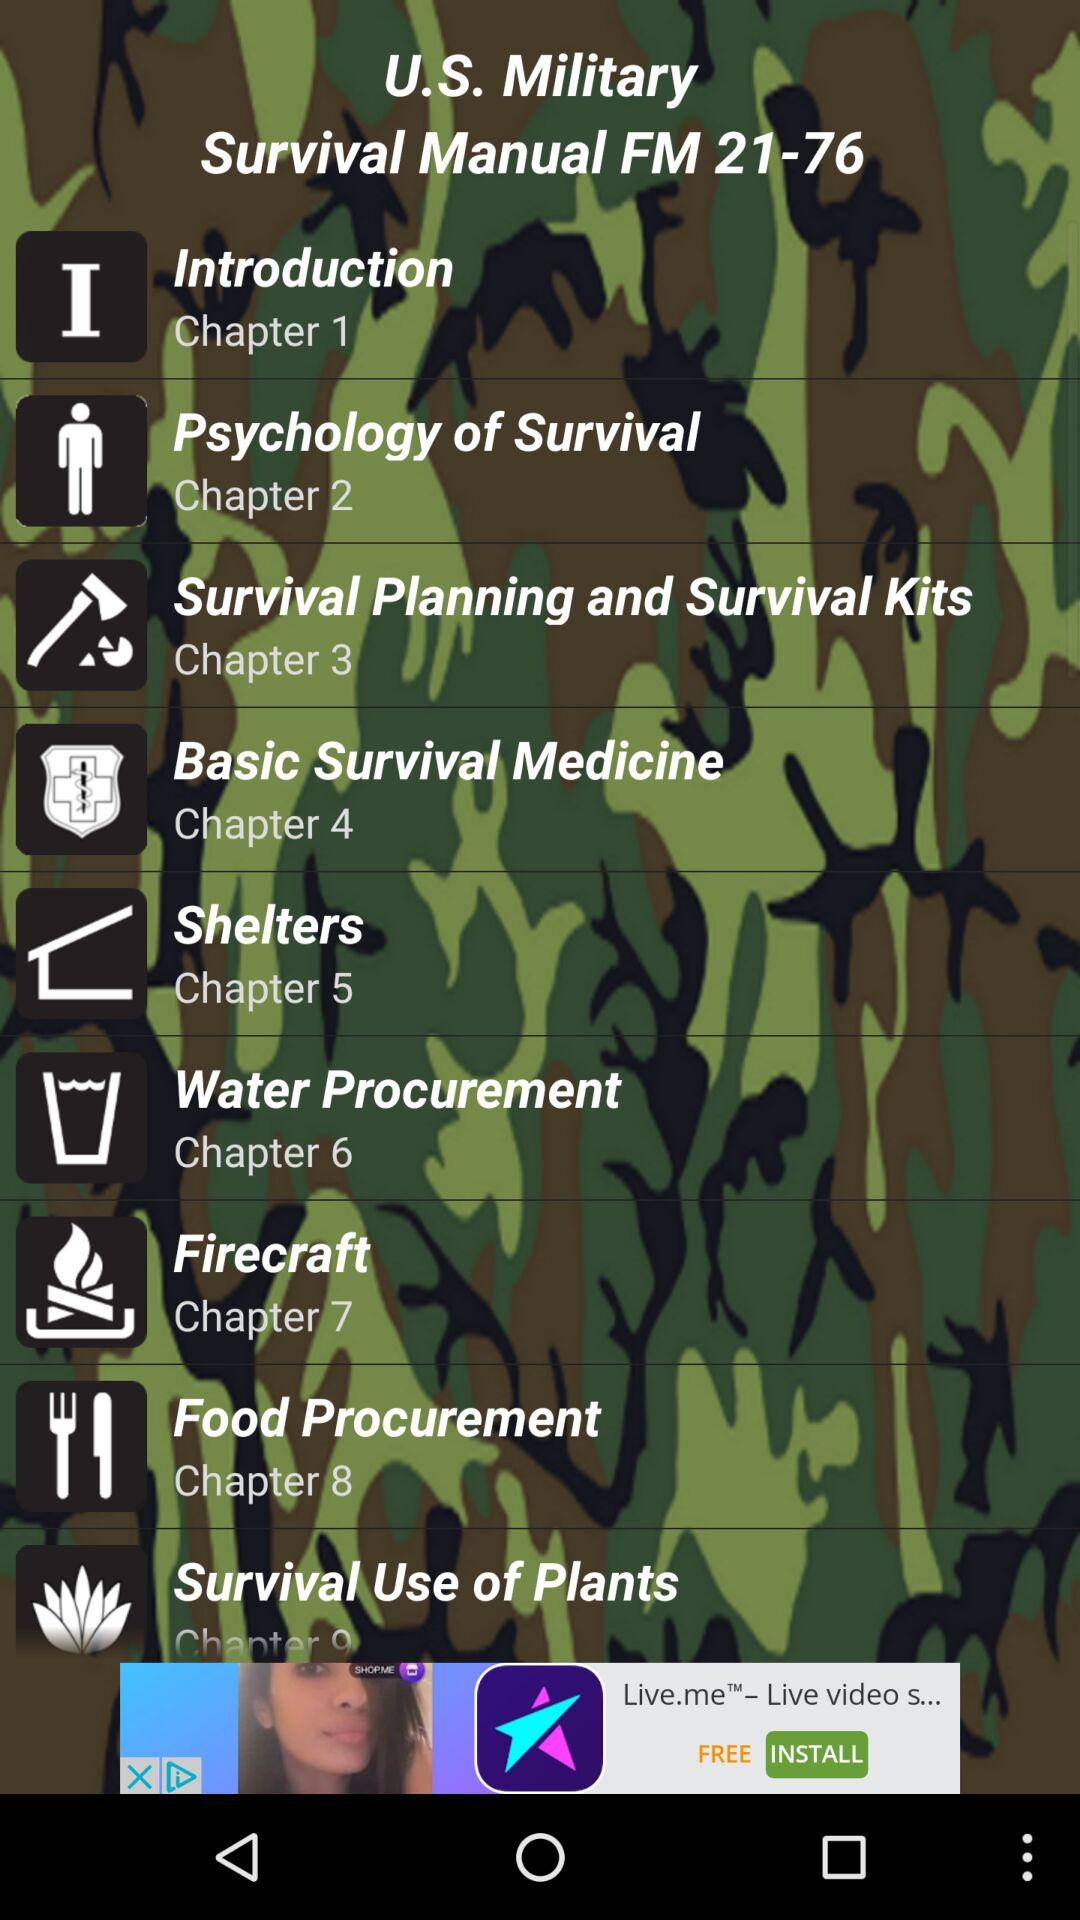What is the title of chapter 5? The title of chapter 5 is "Shelters". 